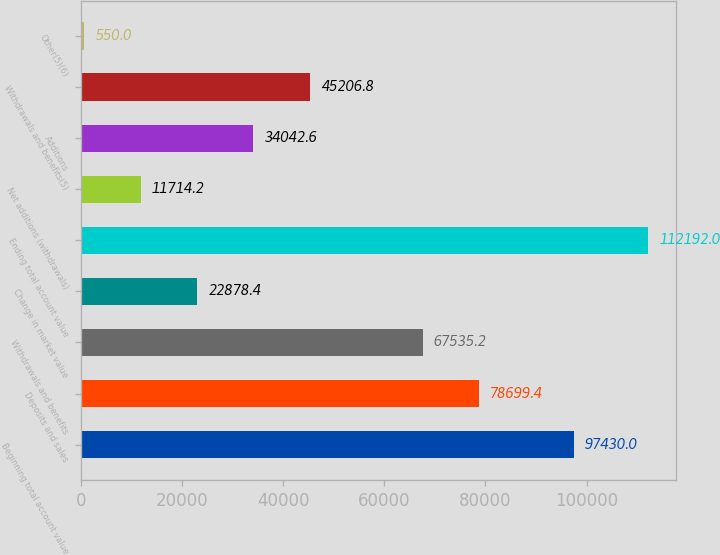Convert chart. <chart><loc_0><loc_0><loc_500><loc_500><bar_chart><fcel>Beginning total account value<fcel>Deposits and sales<fcel>Withdrawals and benefits<fcel>Change in market value<fcel>Ending total account value<fcel>Net additions (withdrawals)<fcel>Additions<fcel>Withdrawals and benefits(5)<fcel>Other(5)(6)<nl><fcel>97430<fcel>78699.4<fcel>67535.2<fcel>22878.4<fcel>112192<fcel>11714.2<fcel>34042.6<fcel>45206.8<fcel>550<nl></chart> 